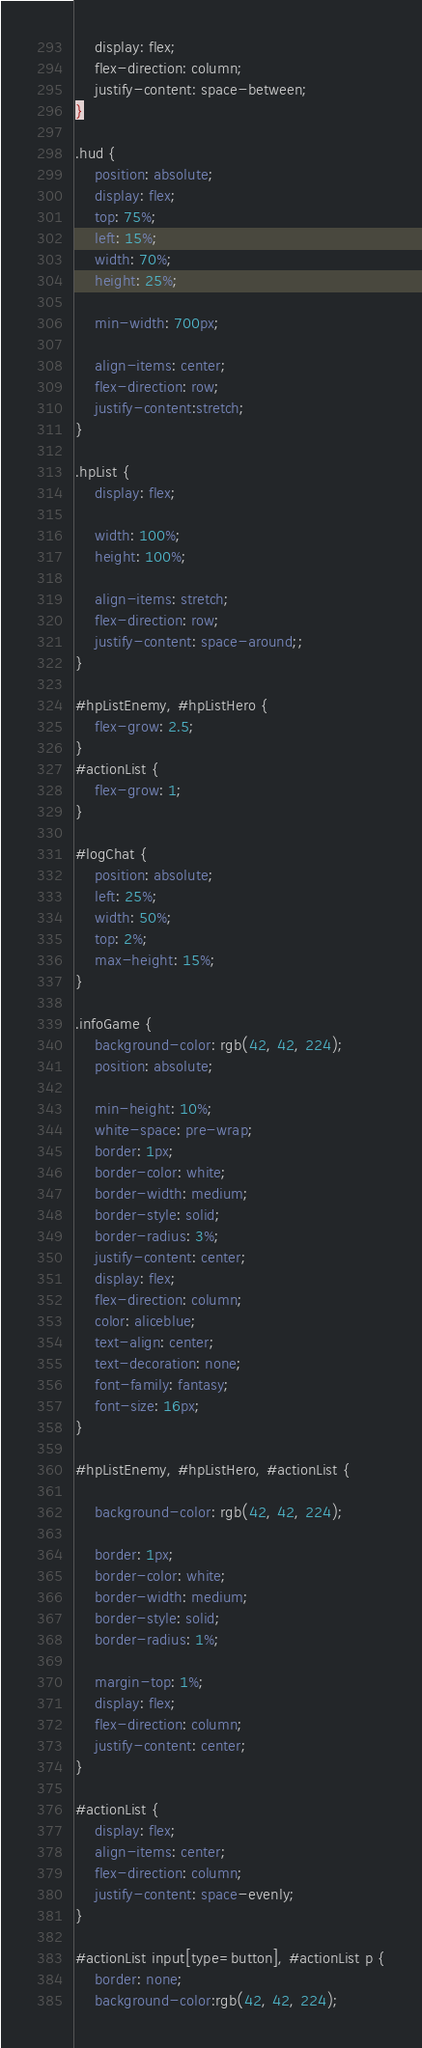Convert code to text. <code><loc_0><loc_0><loc_500><loc_500><_CSS_>
	display: flex;
	flex-direction: column;
	justify-content: space-between;
}

.hud {
	position: absolute;
	display: flex;
	top: 75%;
	left: 15%;
	width: 70%;
	height: 25%;

	min-width: 700px;

	align-items: center;
	flex-direction: row;
	justify-content:stretch;
}

.hpList {
	display: flex;

	width: 100%;
	height: 100%;

	align-items: stretch;
	flex-direction: row;
	justify-content: space-around;;
}

#hpListEnemy, #hpListHero {
	flex-grow: 2.5;
}
#actionList {
	flex-grow: 1;
}

#logChat {
	position: absolute;
	left: 25%;
	width: 50%;
	top: 2%;
	max-height: 15%;
}

.infoGame {
	background-color: rgb(42, 42, 224);
	position: absolute;

	min-height: 10%;
	white-space: pre-wrap;
	border: 1px;
	border-color: white;
	border-width: medium;
	border-style: solid;
	border-radius: 3%;
	justify-content: center;
	display: flex;
	flex-direction: column;
	color: aliceblue;
	text-align: center;
  	text-decoration: none;
	font-family: fantasy;
	font-size: 16px;
}

#hpListEnemy, #hpListHero, #actionList {

	background-color: rgb(42, 42, 224);

	border: 1px;
	border-color: white;
	border-width: medium;
	border-style: solid;
	border-radius: 1%;

	margin-top: 1%;
	display: flex;
	flex-direction: column;
	justify-content: center;
}

#actionList {
	display: flex;
	align-items: center;
	flex-direction: column;
	justify-content: space-evenly;
}

#actionList input[type=button], #actionList p {
	border: none;
	background-color:rgb(42, 42, 224);</code> 